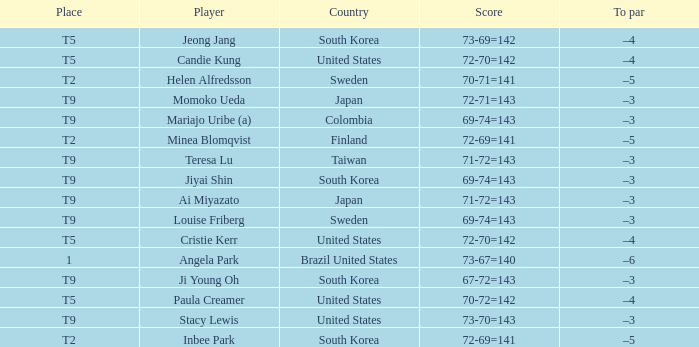Who scored 69-74=143 for Colombia? Mariajo Uribe (a). 